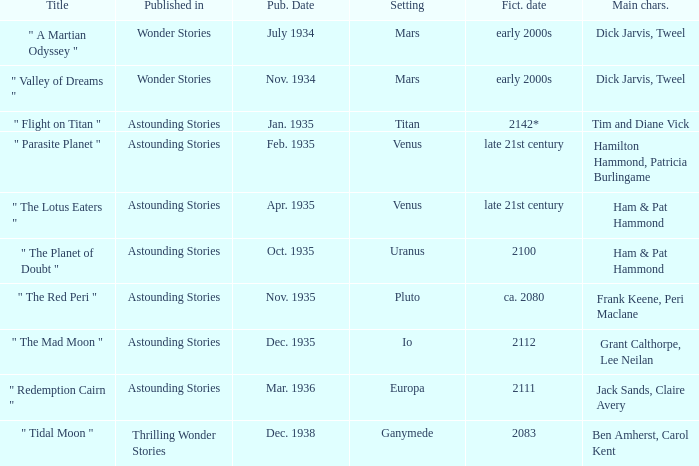Name the title when the main characters are grant calthorpe, lee neilan and the published in of astounding stories " The Mad Moon ". 